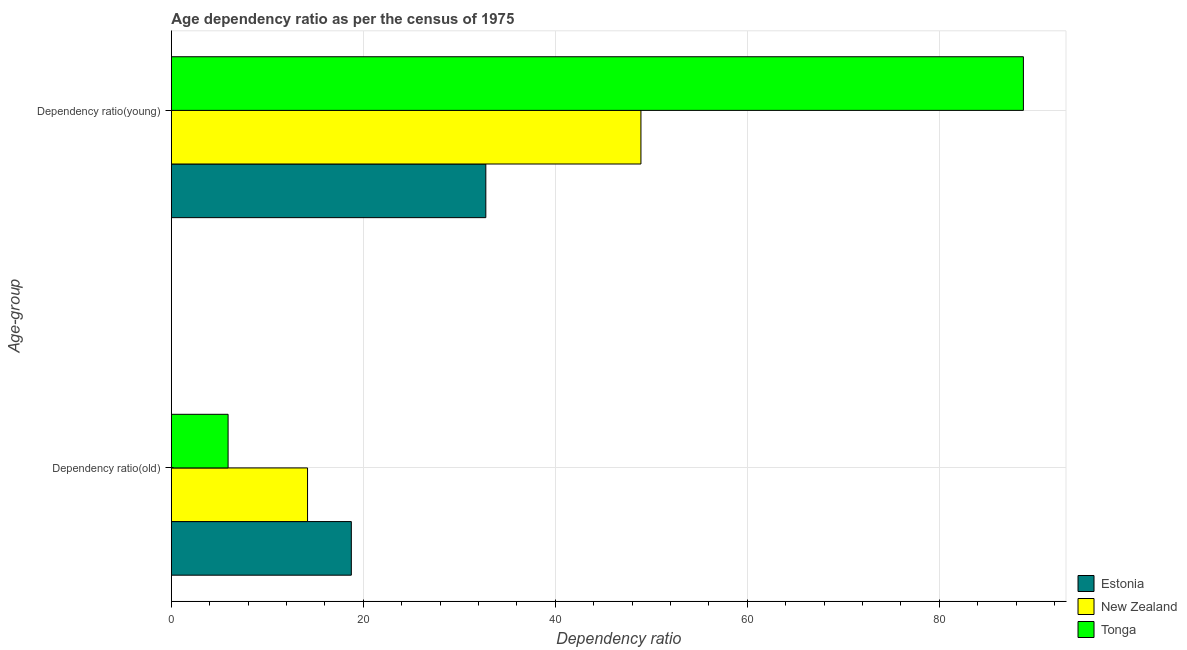How many groups of bars are there?
Offer a terse response. 2. Are the number of bars on each tick of the Y-axis equal?
Keep it short and to the point. Yes. How many bars are there on the 1st tick from the top?
Your answer should be compact. 3. What is the label of the 2nd group of bars from the top?
Offer a very short reply. Dependency ratio(old). What is the age dependency ratio(young) in New Zealand?
Offer a terse response. 48.91. Across all countries, what is the maximum age dependency ratio(old)?
Ensure brevity in your answer.  18.75. Across all countries, what is the minimum age dependency ratio(old)?
Make the answer very short. 5.91. In which country was the age dependency ratio(young) maximum?
Your answer should be compact. Tonga. In which country was the age dependency ratio(young) minimum?
Offer a very short reply. Estonia. What is the total age dependency ratio(young) in the graph?
Keep it short and to the point. 170.42. What is the difference between the age dependency ratio(young) in Estonia and that in New Zealand?
Your answer should be compact. -16.16. What is the difference between the age dependency ratio(old) in Tonga and the age dependency ratio(young) in Estonia?
Your response must be concise. -26.85. What is the average age dependency ratio(old) per country?
Give a very brief answer. 12.95. What is the difference between the age dependency ratio(young) and age dependency ratio(old) in New Zealand?
Provide a short and direct response. 34.73. In how many countries, is the age dependency ratio(old) greater than 24 ?
Your answer should be very brief. 0. What is the ratio of the age dependency ratio(young) in New Zealand to that in Tonga?
Give a very brief answer. 0.55. What does the 2nd bar from the top in Dependency ratio(young) represents?
Provide a succinct answer. New Zealand. What does the 2nd bar from the bottom in Dependency ratio(young) represents?
Keep it short and to the point. New Zealand. Are all the bars in the graph horizontal?
Keep it short and to the point. Yes. Are the values on the major ticks of X-axis written in scientific E-notation?
Your response must be concise. No. Does the graph contain any zero values?
Offer a very short reply. No. Does the graph contain grids?
Offer a very short reply. Yes. Where does the legend appear in the graph?
Your answer should be compact. Bottom right. How many legend labels are there?
Your response must be concise. 3. How are the legend labels stacked?
Provide a succinct answer. Vertical. What is the title of the graph?
Make the answer very short. Age dependency ratio as per the census of 1975. Does "Nicaragua" appear as one of the legend labels in the graph?
Your answer should be very brief. No. What is the label or title of the X-axis?
Your answer should be very brief. Dependency ratio. What is the label or title of the Y-axis?
Offer a terse response. Age-group. What is the Dependency ratio in Estonia in Dependency ratio(old)?
Your answer should be very brief. 18.75. What is the Dependency ratio of New Zealand in Dependency ratio(old)?
Offer a terse response. 14.18. What is the Dependency ratio in Tonga in Dependency ratio(old)?
Offer a very short reply. 5.91. What is the Dependency ratio of Estonia in Dependency ratio(young)?
Your answer should be very brief. 32.76. What is the Dependency ratio in New Zealand in Dependency ratio(young)?
Make the answer very short. 48.91. What is the Dependency ratio in Tonga in Dependency ratio(young)?
Make the answer very short. 88.75. Across all Age-group, what is the maximum Dependency ratio in Estonia?
Offer a terse response. 32.76. Across all Age-group, what is the maximum Dependency ratio of New Zealand?
Give a very brief answer. 48.91. Across all Age-group, what is the maximum Dependency ratio in Tonga?
Your answer should be very brief. 88.75. Across all Age-group, what is the minimum Dependency ratio of Estonia?
Offer a terse response. 18.75. Across all Age-group, what is the minimum Dependency ratio of New Zealand?
Keep it short and to the point. 14.18. Across all Age-group, what is the minimum Dependency ratio of Tonga?
Offer a terse response. 5.91. What is the total Dependency ratio in Estonia in the graph?
Provide a short and direct response. 51.5. What is the total Dependency ratio in New Zealand in the graph?
Your response must be concise. 63.1. What is the total Dependency ratio in Tonga in the graph?
Provide a succinct answer. 94.66. What is the difference between the Dependency ratio in Estonia in Dependency ratio(old) and that in Dependency ratio(young)?
Your response must be concise. -14.01. What is the difference between the Dependency ratio in New Zealand in Dependency ratio(old) and that in Dependency ratio(young)?
Ensure brevity in your answer.  -34.73. What is the difference between the Dependency ratio of Tonga in Dependency ratio(old) and that in Dependency ratio(young)?
Provide a short and direct response. -82.85. What is the difference between the Dependency ratio of Estonia in Dependency ratio(old) and the Dependency ratio of New Zealand in Dependency ratio(young)?
Ensure brevity in your answer.  -30.17. What is the difference between the Dependency ratio in Estonia in Dependency ratio(old) and the Dependency ratio in Tonga in Dependency ratio(young)?
Your response must be concise. -70.01. What is the difference between the Dependency ratio in New Zealand in Dependency ratio(old) and the Dependency ratio in Tonga in Dependency ratio(young)?
Offer a terse response. -74.57. What is the average Dependency ratio of Estonia per Age-group?
Provide a succinct answer. 25.75. What is the average Dependency ratio in New Zealand per Age-group?
Offer a terse response. 31.55. What is the average Dependency ratio in Tonga per Age-group?
Provide a succinct answer. 47.33. What is the difference between the Dependency ratio of Estonia and Dependency ratio of New Zealand in Dependency ratio(old)?
Your answer should be very brief. 4.56. What is the difference between the Dependency ratio in Estonia and Dependency ratio in Tonga in Dependency ratio(old)?
Ensure brevity in your answer.  12.84. What is the difference between the Dependency ratio in New Zealand and Dependency ratio in Tonga in Dependency ratio(old)?
Ensure brevity in your answer.  8.28. What is the difference between the Dependency ratio in Estonia and Dependency ratio in New Zealand in Dependency ratio(young)?
Keep it short and to the point. -16.16. What is the difference between the Dependency ratio in Estonia and Dependency ratio in Tonga in Dependency ratio(young)?
Offer a very short reply. -56. What is the difference between the Dependency ratio of New Zealand and Dependency ratio of Tonga in Dependency ratio(young)?
Offer a terse response. -39.84. What is the ratio of the Dependency ratio of Estonia in Dependency ratio(old) to that in Dependency ratio(young)?
Offer a very short reply. 0.57. What is the ratio of the Dependency ratio in New Zealand in Dependency ratio(old) to that in Dependency ratio(young)?
Offer a very short reply. 0.29. What is the ratio of the Dependency ratio of Tonga in Dependency ratio(old) to that in Dependency ratio(young)?
Provide a short and direct response. 0.07. What is the difference between the highest and the second highest Dependency ratio of Estonia?
Offer a very short reply. 14.01. What is the difference between the highest and the second highest Dependency ratio in New Zealand?
Ensure brevity in your answer.  34.73. What is the difference between the highest and the second highest Dependency ratio in Tonga?
Give a very brief answer. 82.85. What is the difference between the highest and the lowest Dependency ratio of Estonia?
Provide a succinct answer. 14.01. What is the difference between the highest and the lowest Dependency ratio in New Zealand?
Your response must be concise. 34.73. What is the difference between the highest and the lowest Dependency ratio of Tonga?
Offer a very short reply. 82.85. 